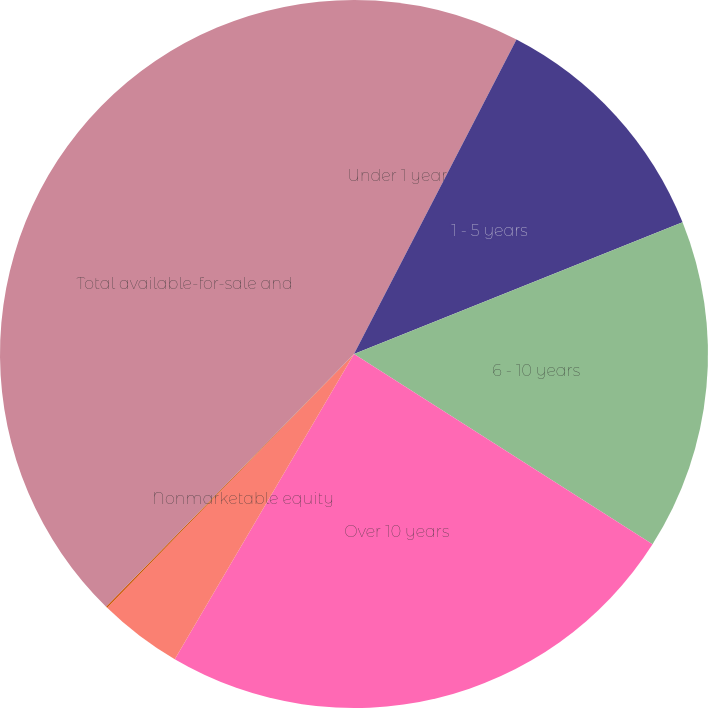Convert chart. <chart><loc_0><loc_0><loc_500><loc_500><pie_chart><fcel>Under 1 year<fcel>1 - 5 years<fcel>6 - 10 years<fcel>Over 10 years<fcel>Nonmarketable equity<fcel>Marketable equity securities<fcel>Total available-for-sale and<nl><fcel>7.59%<fcel>11.34%<fcel>15.1%<fcel>24.42%<fcel>3.83%<fcel>0.07%<fcel>37.65%<nl></chart> 